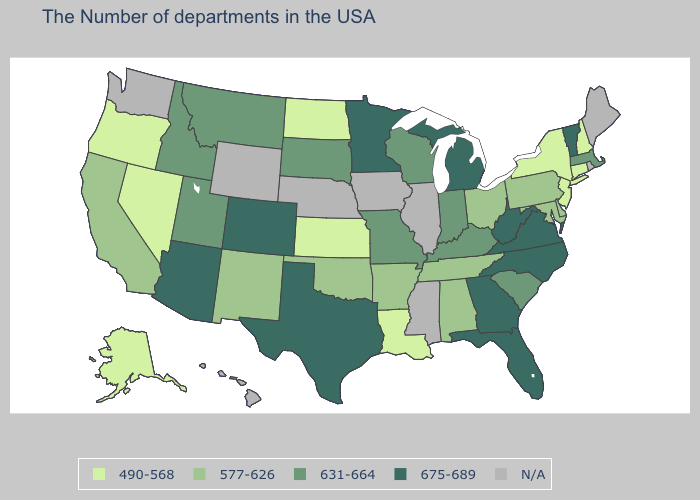Does Massachusetts have the lowest value in the Northeast?
Keep it brief. No. Does West Virginia have the highest value in the USA?
Keep it brief. Yes. Which states hav the highest value in the Northeast?
Short answer required. Vermont. What is the value of Colorado?
Give a very brief answer. 675-689. What is the value of Kentucky?
Keep it brief. 631-664. Does the map have missing data?
Write a very short answer. Yes. Among the states that border South Dakota , which have the lowest value?
Concise answer only. North Dakota. Name the states that have a value in the range N/A?
Write a very short answer. Maine, Rhode Island, Illinois, Mississippi, Iowa, Nebraska, Wyoming, Washington, Hawaii. Which states have the highest value in the USA?
Write a very short answer. Vermont, Virginia, North Carolina, West Virginia, Florida, Georgia, Michigan, Minnesota, Texas, Colorado, Arizona. Which states have the lowest value in the USA?
Be succinct. New Hampshire, Connecticut, New York, New Jersey, Louisiana, Kansas, North Dakota, Nevada, Oregon, Alaska. What is the lowest value in states that border California?
Give a very brief answer. 490-568. Does Texas have the lowest value in the USA?
Short answer required. No. Among the states that border New York , does New Jersey have the highest value?
Answer briefly. No. 